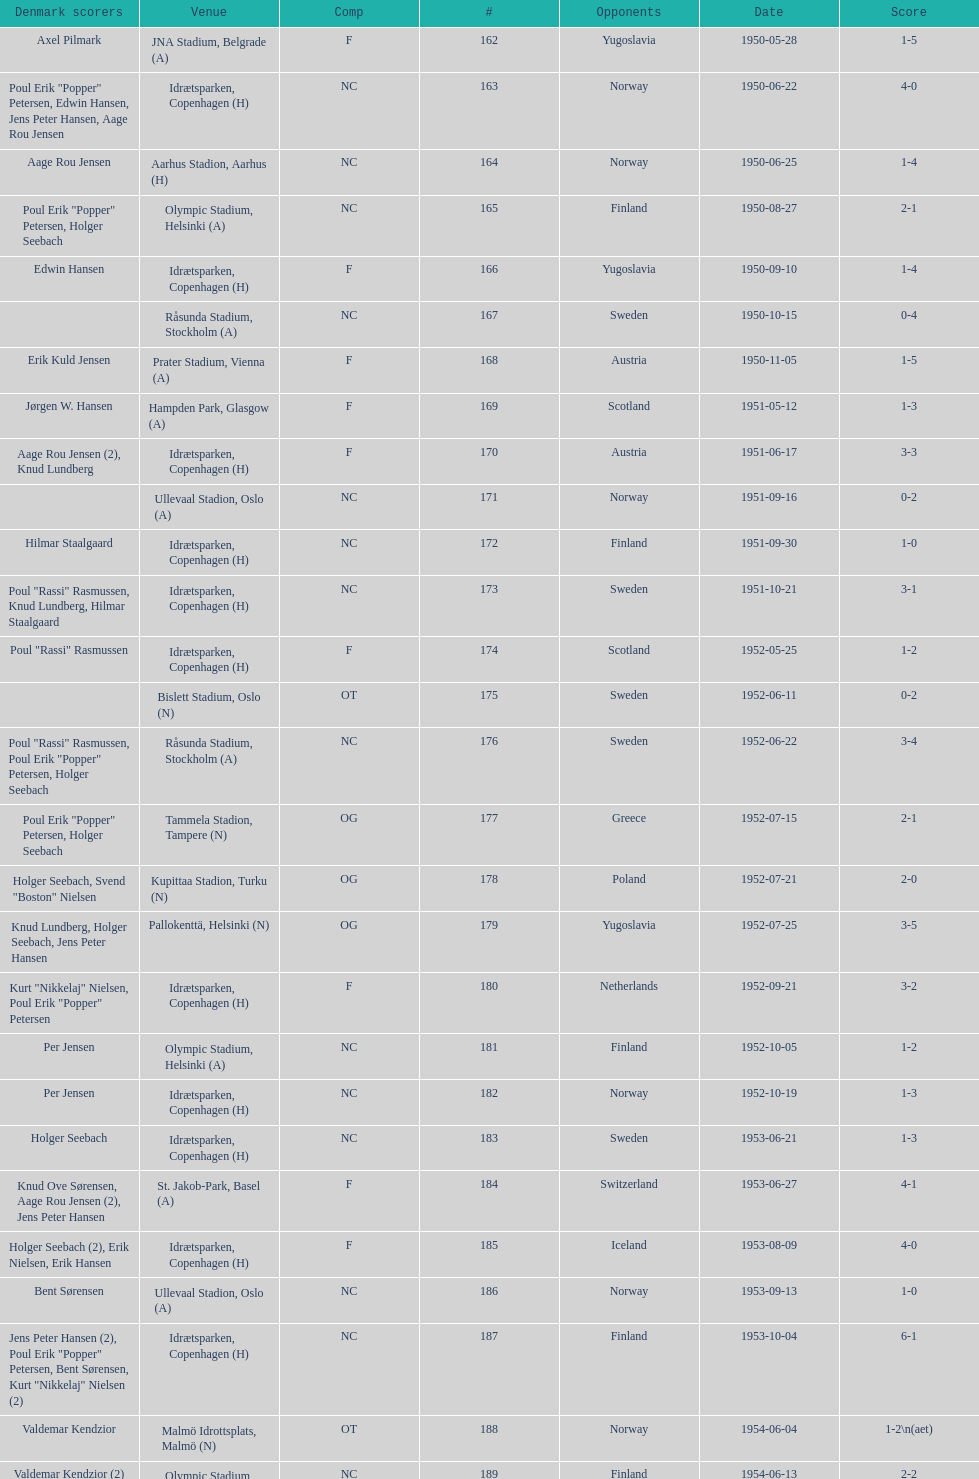What is the venue right below jna stadium, belgrade (a)? Idrætsparken, Copenhagen (H). 